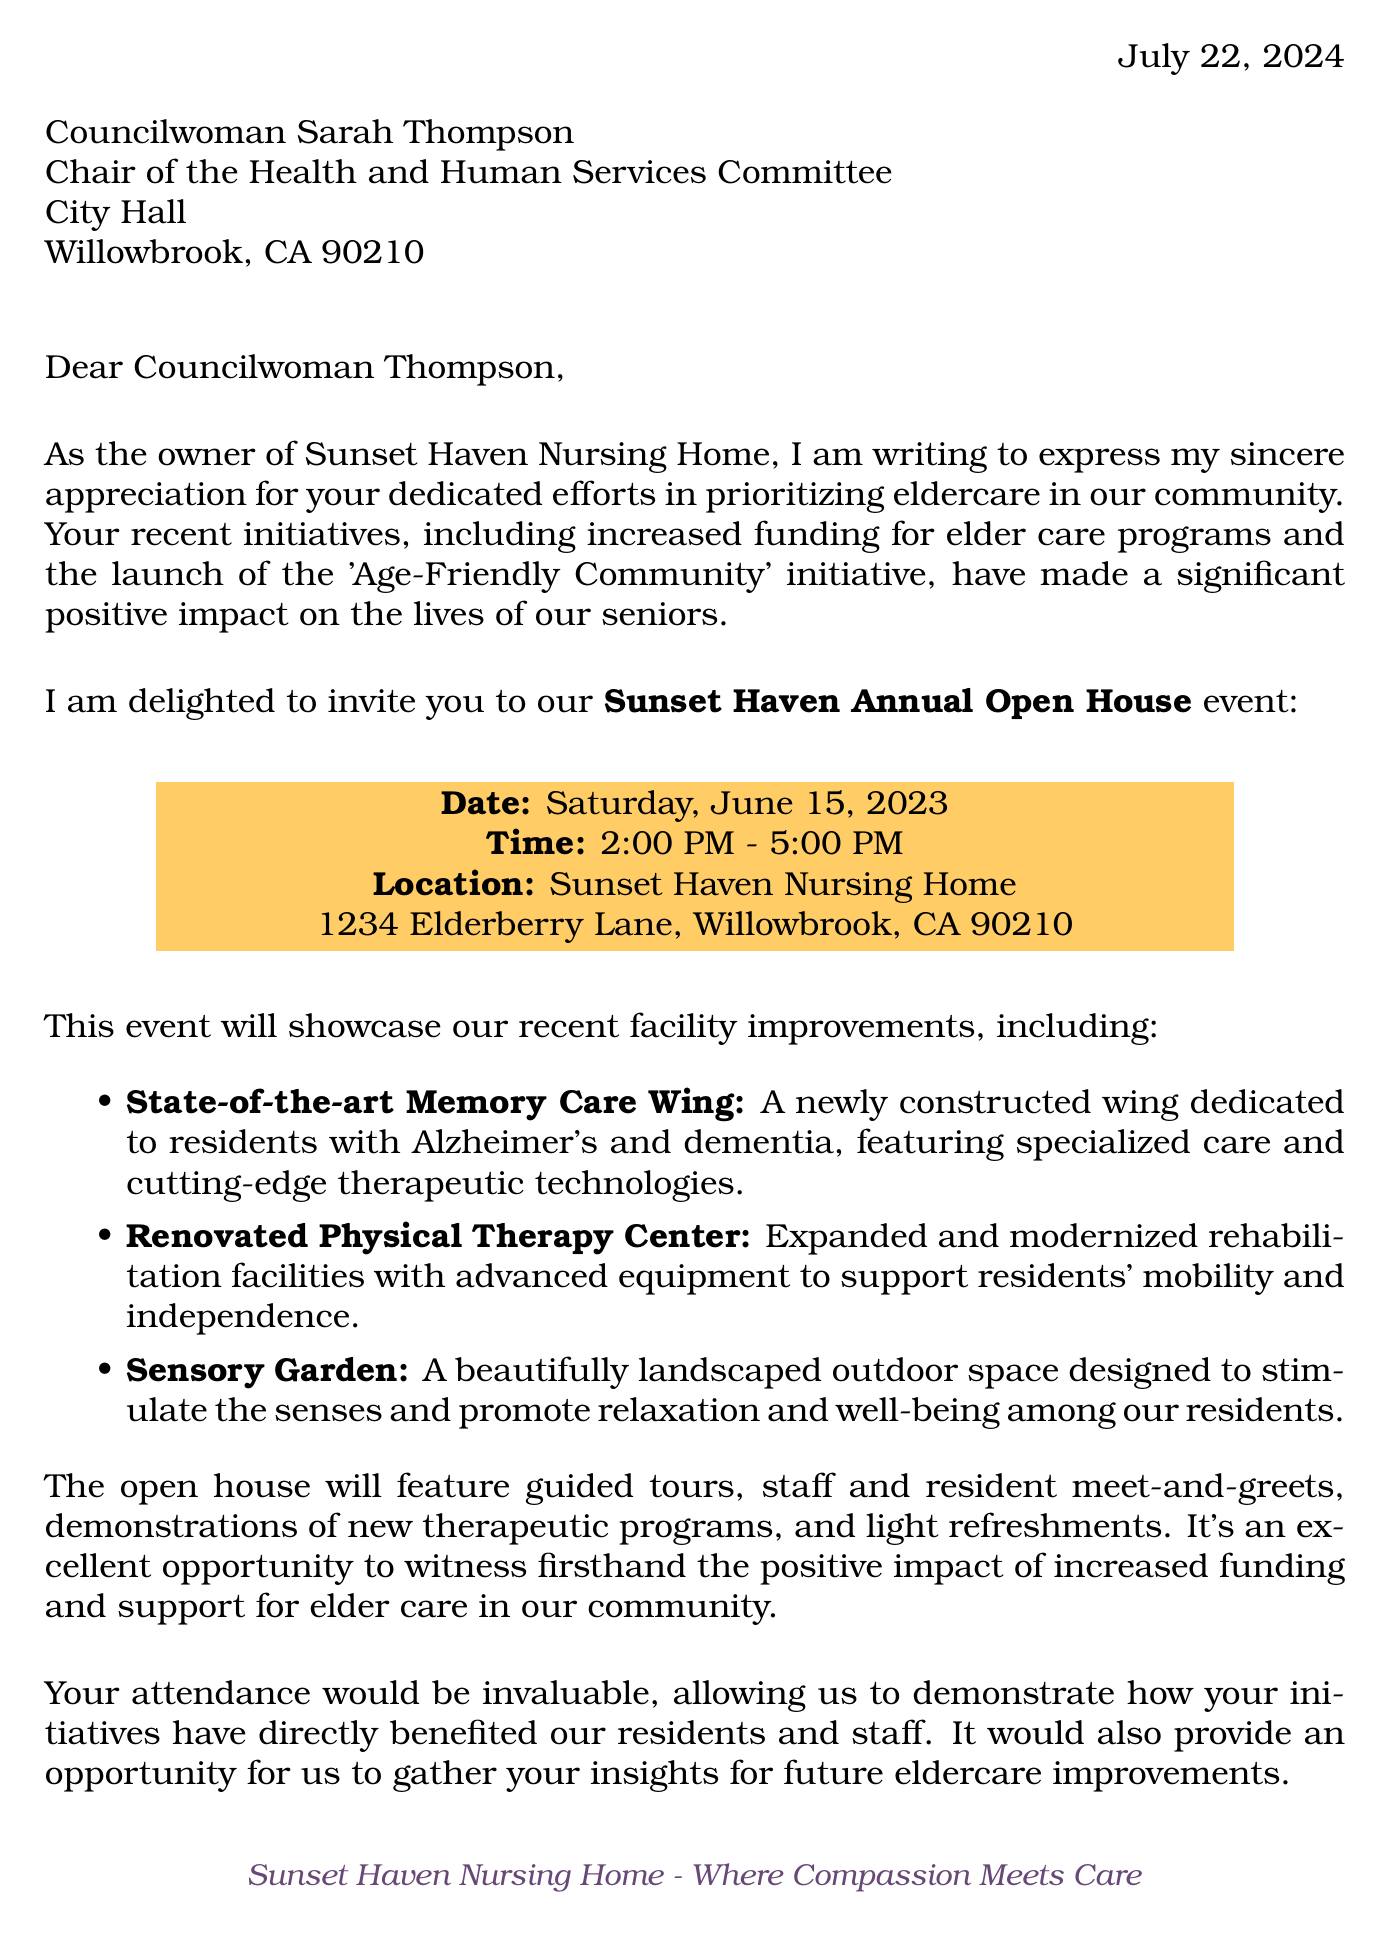What is the date of the open house? The date of the open house is explicitly mentioned in the invitation details as Saturday, June 15, 2023.
Answer: Saturday, June 15, 2023 Who is the council member addressed in the letter? The council member's name is provided at the beginning of the letter.
Answer: Councilwoman Sarah Thompson What is one of the recent initiatives mentioned that supports elder care? The letter lists specific initiatives and one of them is highlighted in the text.
Answer: Increased funding for elder care programs How many jobs were created as a result of the nursing home improvements? The document states a specific number regarding jobs created in the community impact section.
Answer: 15 What is the location of the Sunset Haven Nursing Home? The address of the nursing home is provided in the event details.
Answer: 1234 Elderberry Lane, Willowbrook, CA 90210 What type of facility improvement is mentioned alongside the sensory garden? The document mentions various facility improvements including specific types.
Answer: Renovated Physical Therapy Center What is one activity planned for the open house? The letter lists activities planned for the open house, highlighting one specific type.
Answer: Guided tours of the facility What type of care does Sunset Haven specialize in? The specialties of the nursing home are mentioned, providing insight into the services offered.
Answer: Memory care 